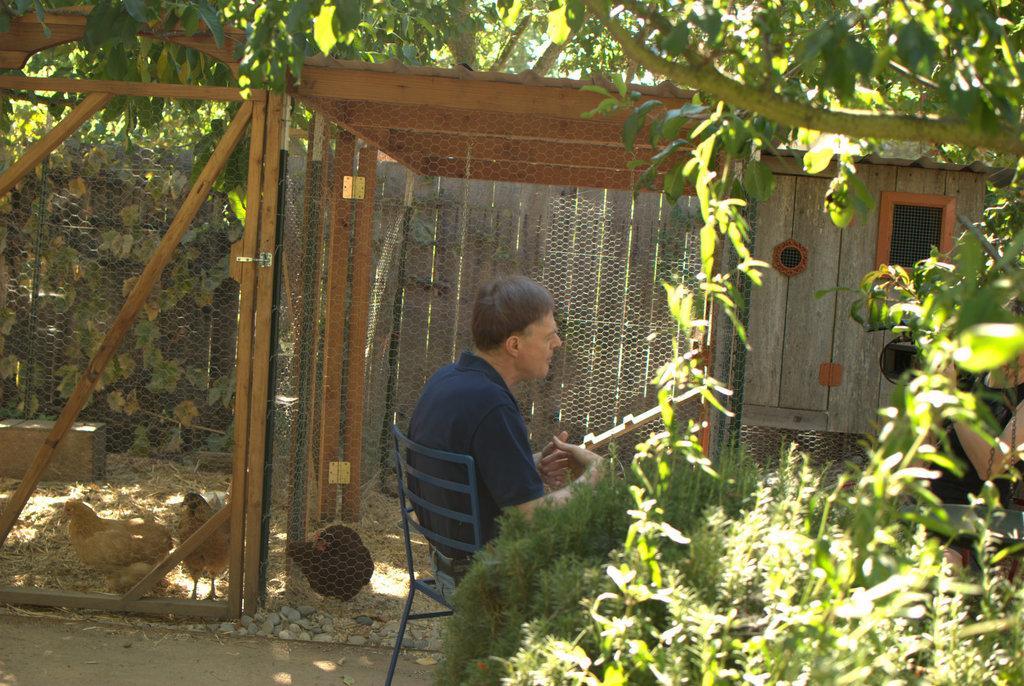Can you describe this image briefly? In this image we can see this person wearing t-shirt is sitting on the chair. Here we can see plants, trees, fence, hens, stone, wooden fence and wooden house in the background. Here we can see a person holding a video camera. 